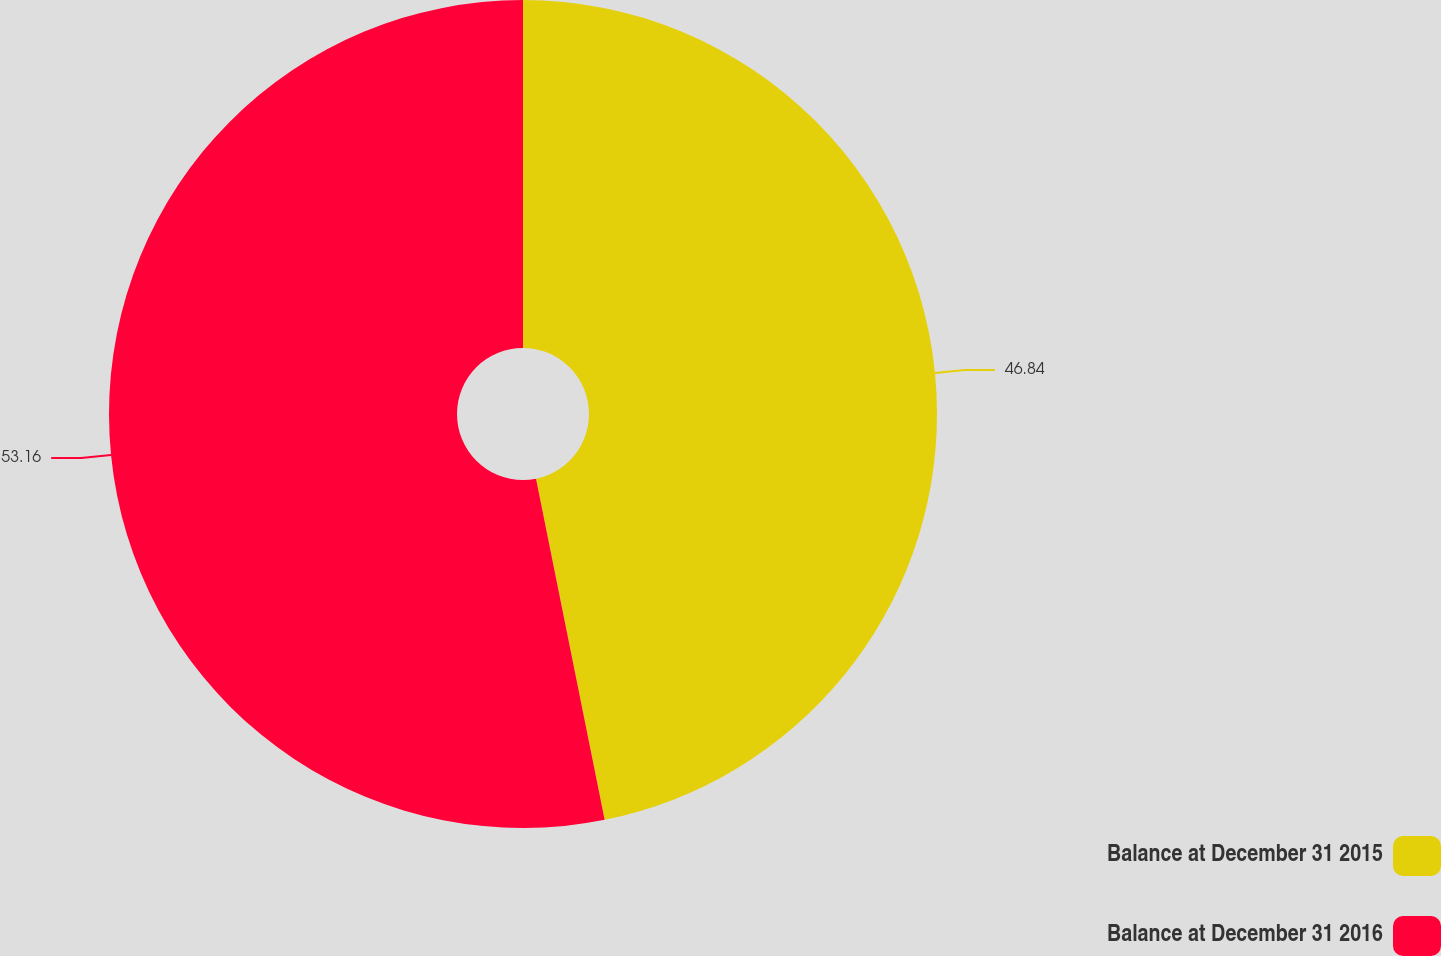<chart> <loc_0><loc_0><loc_500><loc_500><pie_chart><fcel>Balance at December 31 2015<fcel>Balance at December 31 2016<nl><fcel>46.84%<fcel>53.16%<nl></chart> 